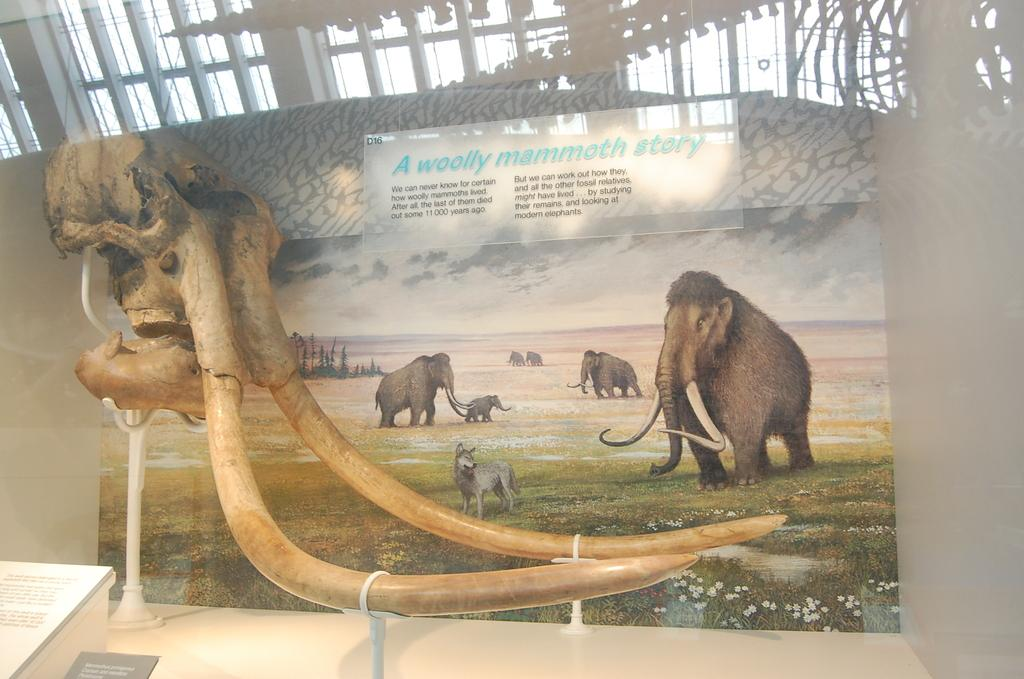What is featured on the poster in the image? The poster contains images of elephants. Are there any words on the poster? Yes, there is text on the poster. Can you describe the tusks of the elephant in the image? The tusks of an elephant are visible in the image. What else in the image has text on it? There is text on a board in the image. What type of street is visible in the image? There is no street visible in the image; it features a poster with images of elephants and text. How does the elephant sneeze in the image? Elephants do not sneeze in the image; it is a static poster with images of elephants. 